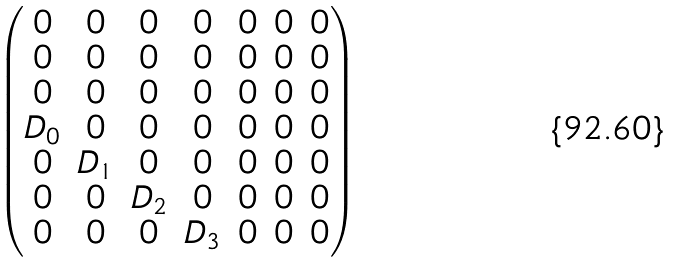<formula> <loc_0><loc_0><loc_500><loc_500>\begin{pmatrix} 0 & 0 & 0 & 0 & 0 & 0 & 0 \\ 0 & 0 & 0 & 0 & 0 & 0 & 0 \\ 0 & 0 & 0 & 0 & 0 & 0 & 0 \\ D _ { 0 } & 0 & 0 & 0 & 0 & 0 & 0 \\ 0 & D _ { 1 } & 0 & 0 & 0 & 0 & 0 \\ 0 & 0 & D _ { 2 } & 0 & 0 & 0 & 0 \\ 0 & 0 & 0 & D _ { 3 } & 0 & 0 & 0 \end{pmatrix}</formula> 